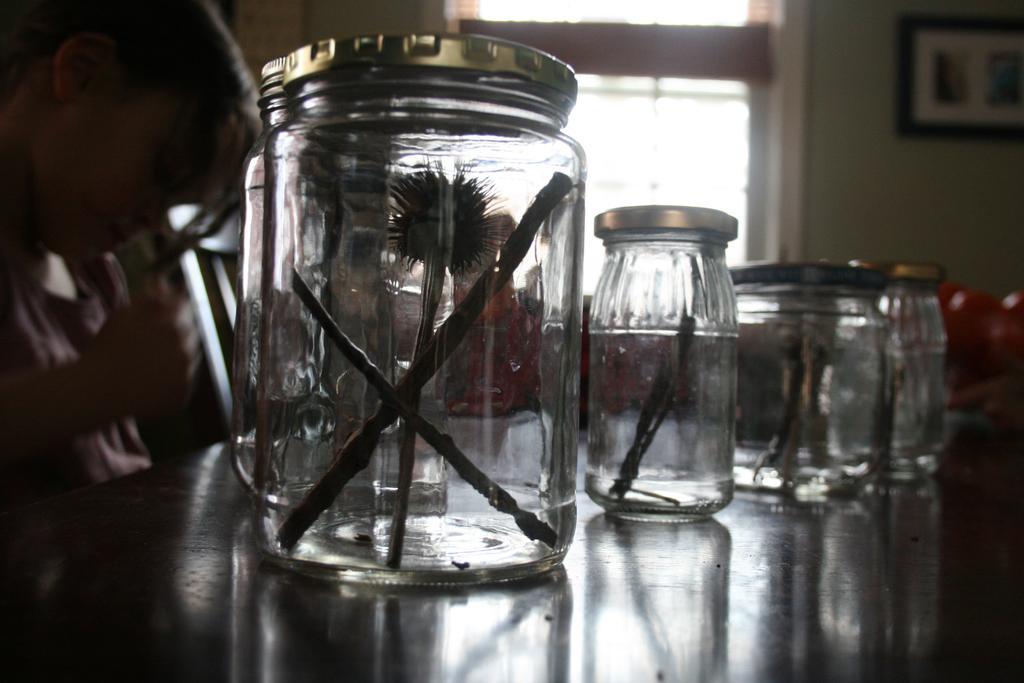Describe this image in one or two sentences. In this picture there are jars placed on the table. On every year, there is an object. Towards the left, there is a person holding a pen. On the top, there is a window to a wall. 